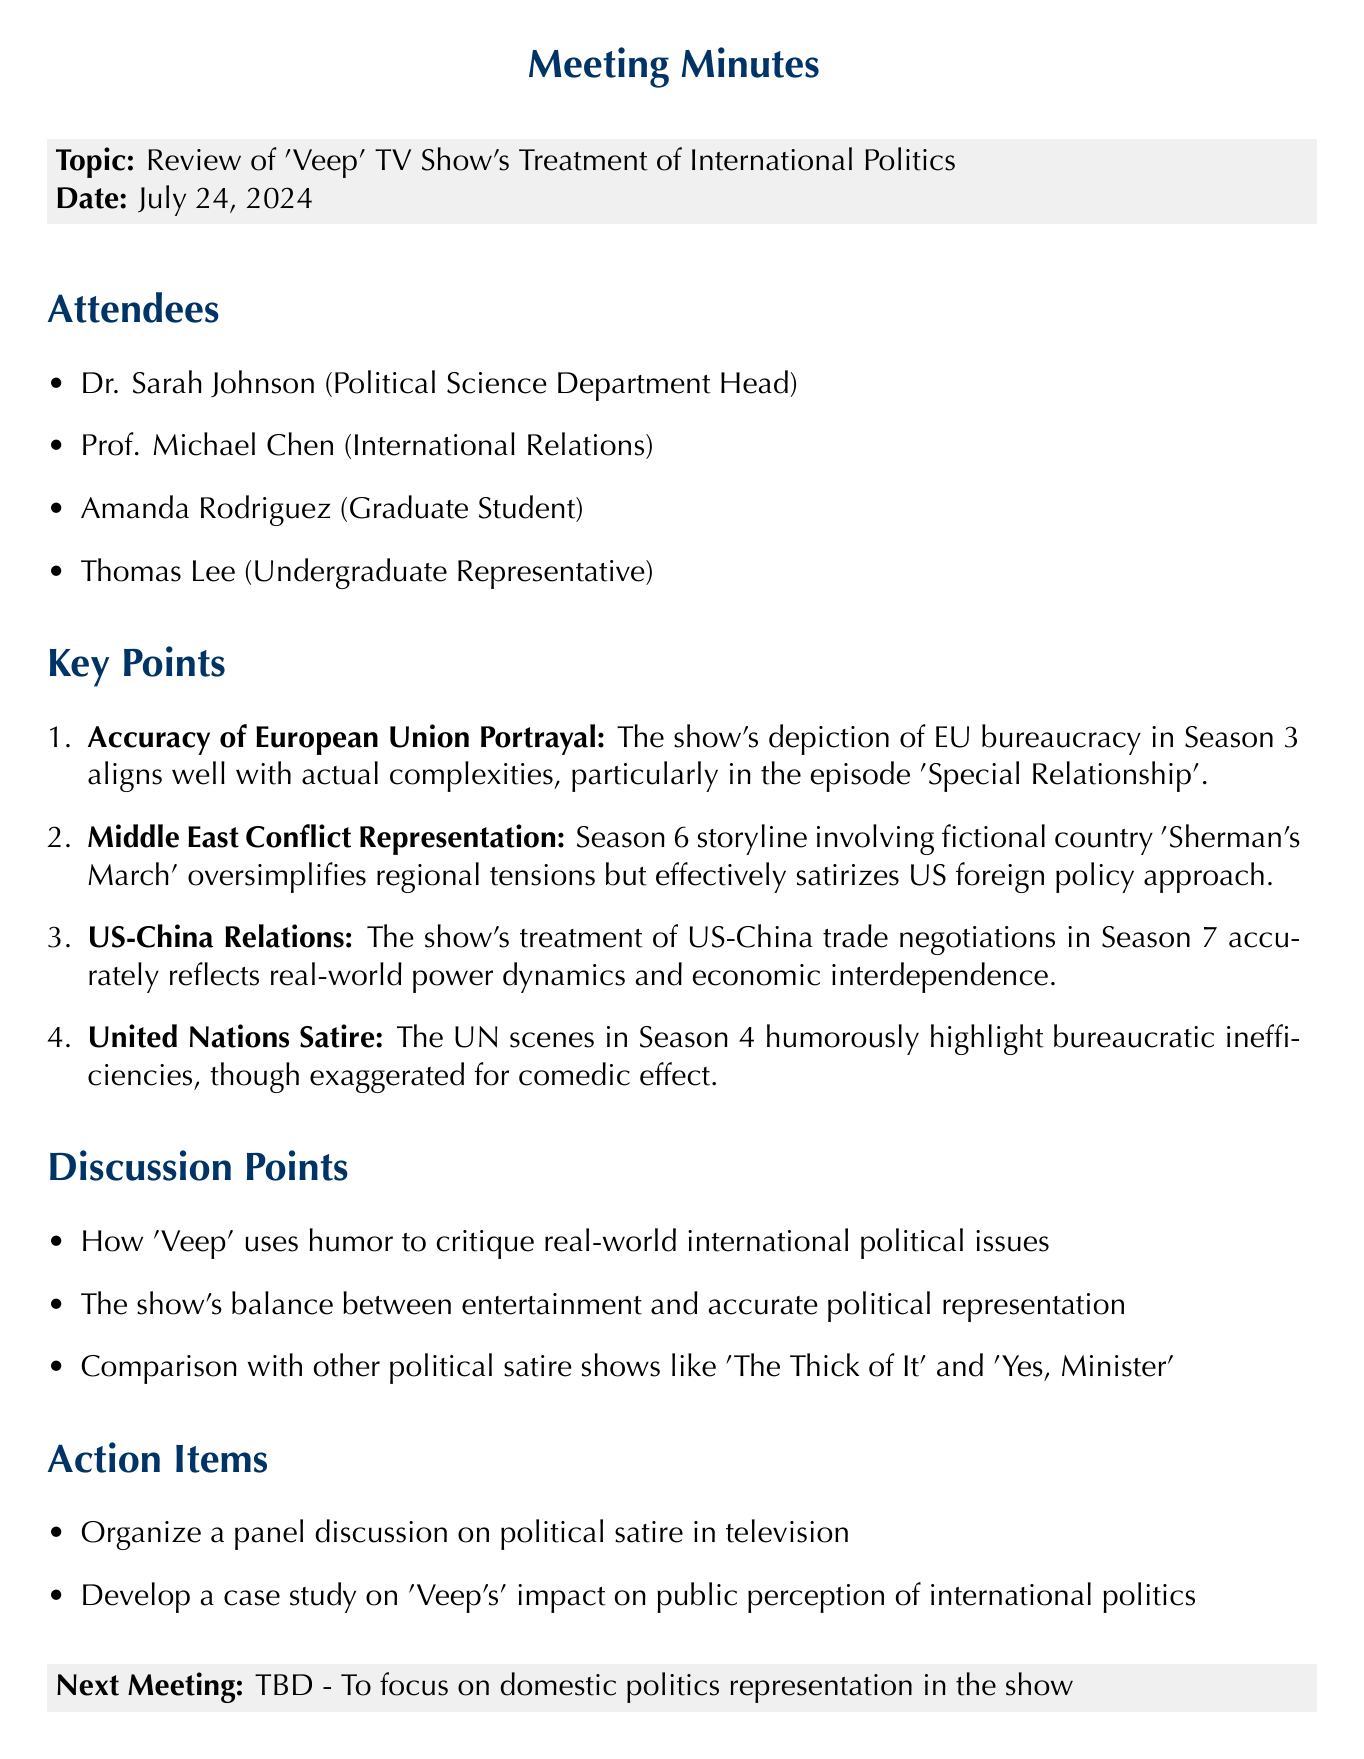What is the meeting topic? The meeting topic is explicitly stated in the document under the title section.
Answer: Review of 'Veep' TV Show's Treatment of International Politics Who is the department head? The department head is mentioned in the list of attendees.
Answer: Dr. Sarah Johnson Which season features the portrayal of the European Union's bureaucracy? The season number is specified in the key points section along with the details.
Answer: Season 3 What fictional country is used in Season 6 to represent the Middle East conflict? The name of the fictional country is noted in the key points section.
Answer: Sherman's March What was one of the discussion points from the meeting? The discussion points are listed, and one can be chosen for specificity.
Answer: How 'Veep' uses humor to critique real-world international political issues How many action items were decided in the meeting? The action items are listed; a direct count will reveal the number.
Answer: 2 What is the next meeting focused on? The focus of the next meeting is mentioned at the end of the document.
Answer: Domestic politics representation in the show In which season does the show humorously highlight bureaucratic inefficiencies in the UN? The specific season is provided in the key points section.
Answer: Season 4 What does the Season 7 storyline reflect in terms of US-China relations? The treatment of US-China relations reflects real-world dynamics as noted.
Answer: Real-world power dynamics and economic interdependence 